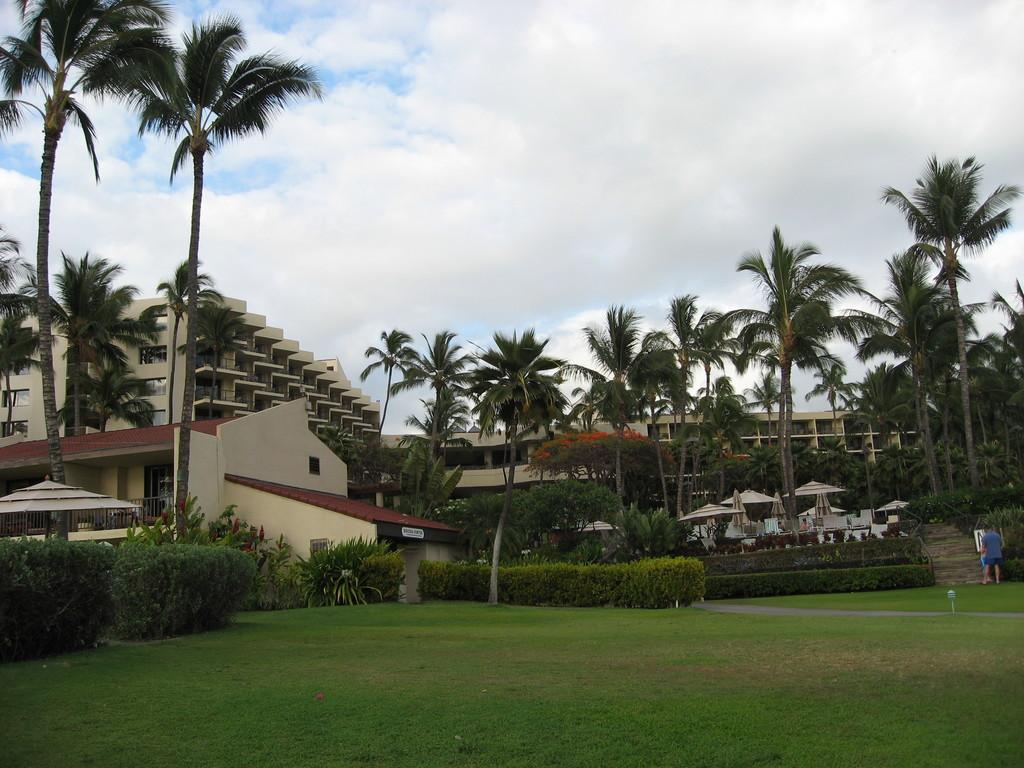What type of structures can be seen in the image? There are buildings in the image. What other natural elements are present in the image? There are trees, plants, and grass on the ground. How would you describe the sky in the image? The sky is blue and cloudy. Can you identify any objects that might be used for sitting in the image? Yes, there are chairs in the image. Are there any objects in the image that might be used for protection from the rain? Yes, there are umbrellas in the image. Can you describe the man standing in the image? There is a man standing in the image, but no specific details about his appearance or clothing are provided. What type of cart is being used to transport the spade in the image? There is no cart or spade present in the image. How many pairs of scissors can be seen in the image? There are no scissors present in the image. 